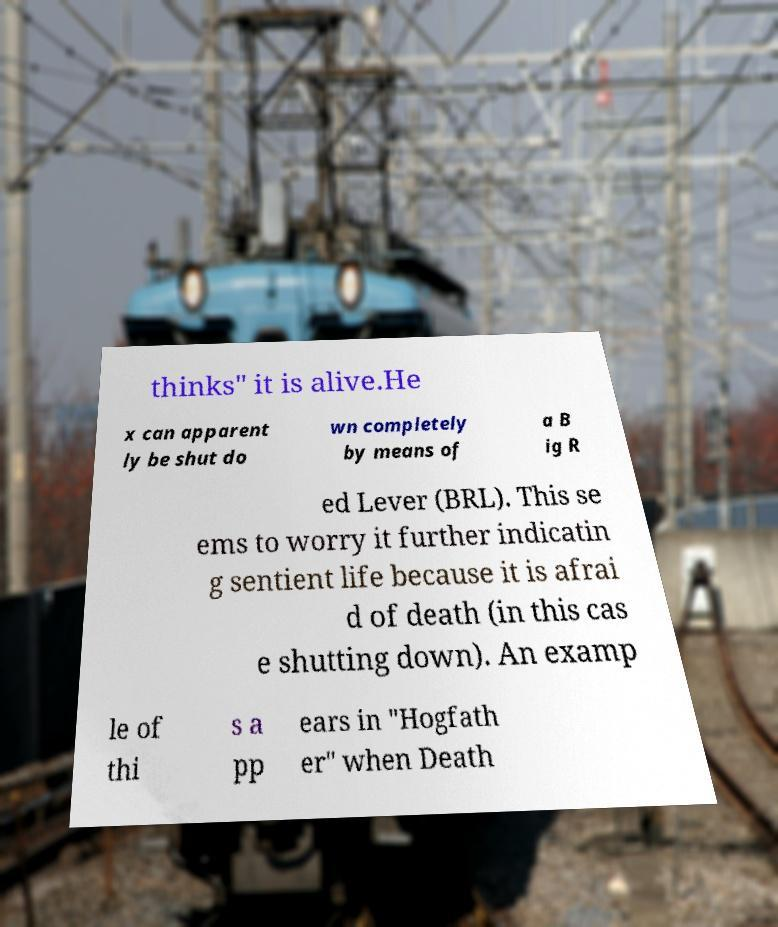Could you extract and type out the text from this image? thinks" it is alive.He x can apparent ly be shut do wn completely by means of a B ig R ed Lever (BRL). This se ems to worry it further indicatin g sentient life because it is afrai d of death (in this cas e shutting down). An examp le of thi s a pp ears in "Hogfath er" when Death 